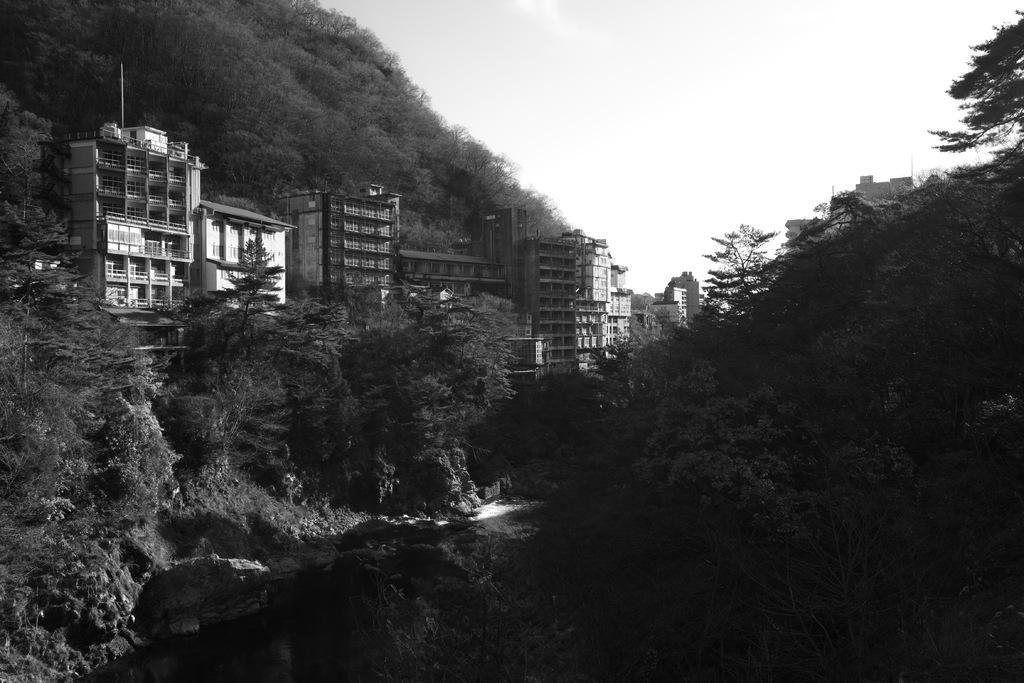How would you summarize this image in a sentence or two? This is a black and white image , where there are trees, buildings, and in the background there is sky. 